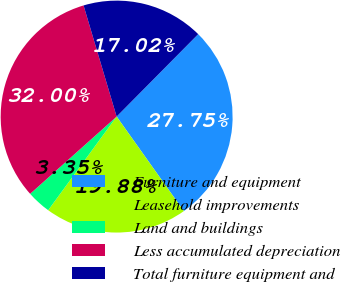Convert chart. <chart><loc_0><loc_0><loc_500><loc_500><pie_chart><fcel>Furniture and equipment<fcel>Leasehold improvements<fcel>Land and buildings<fcel>Less accumulated depreciation<fcel>Total furniture equipment and<nl><fcel>27.75%<fcel>19.88%<fcel>3.35%<fcel>32.0%<fcel>17.02%<nl></chart> 